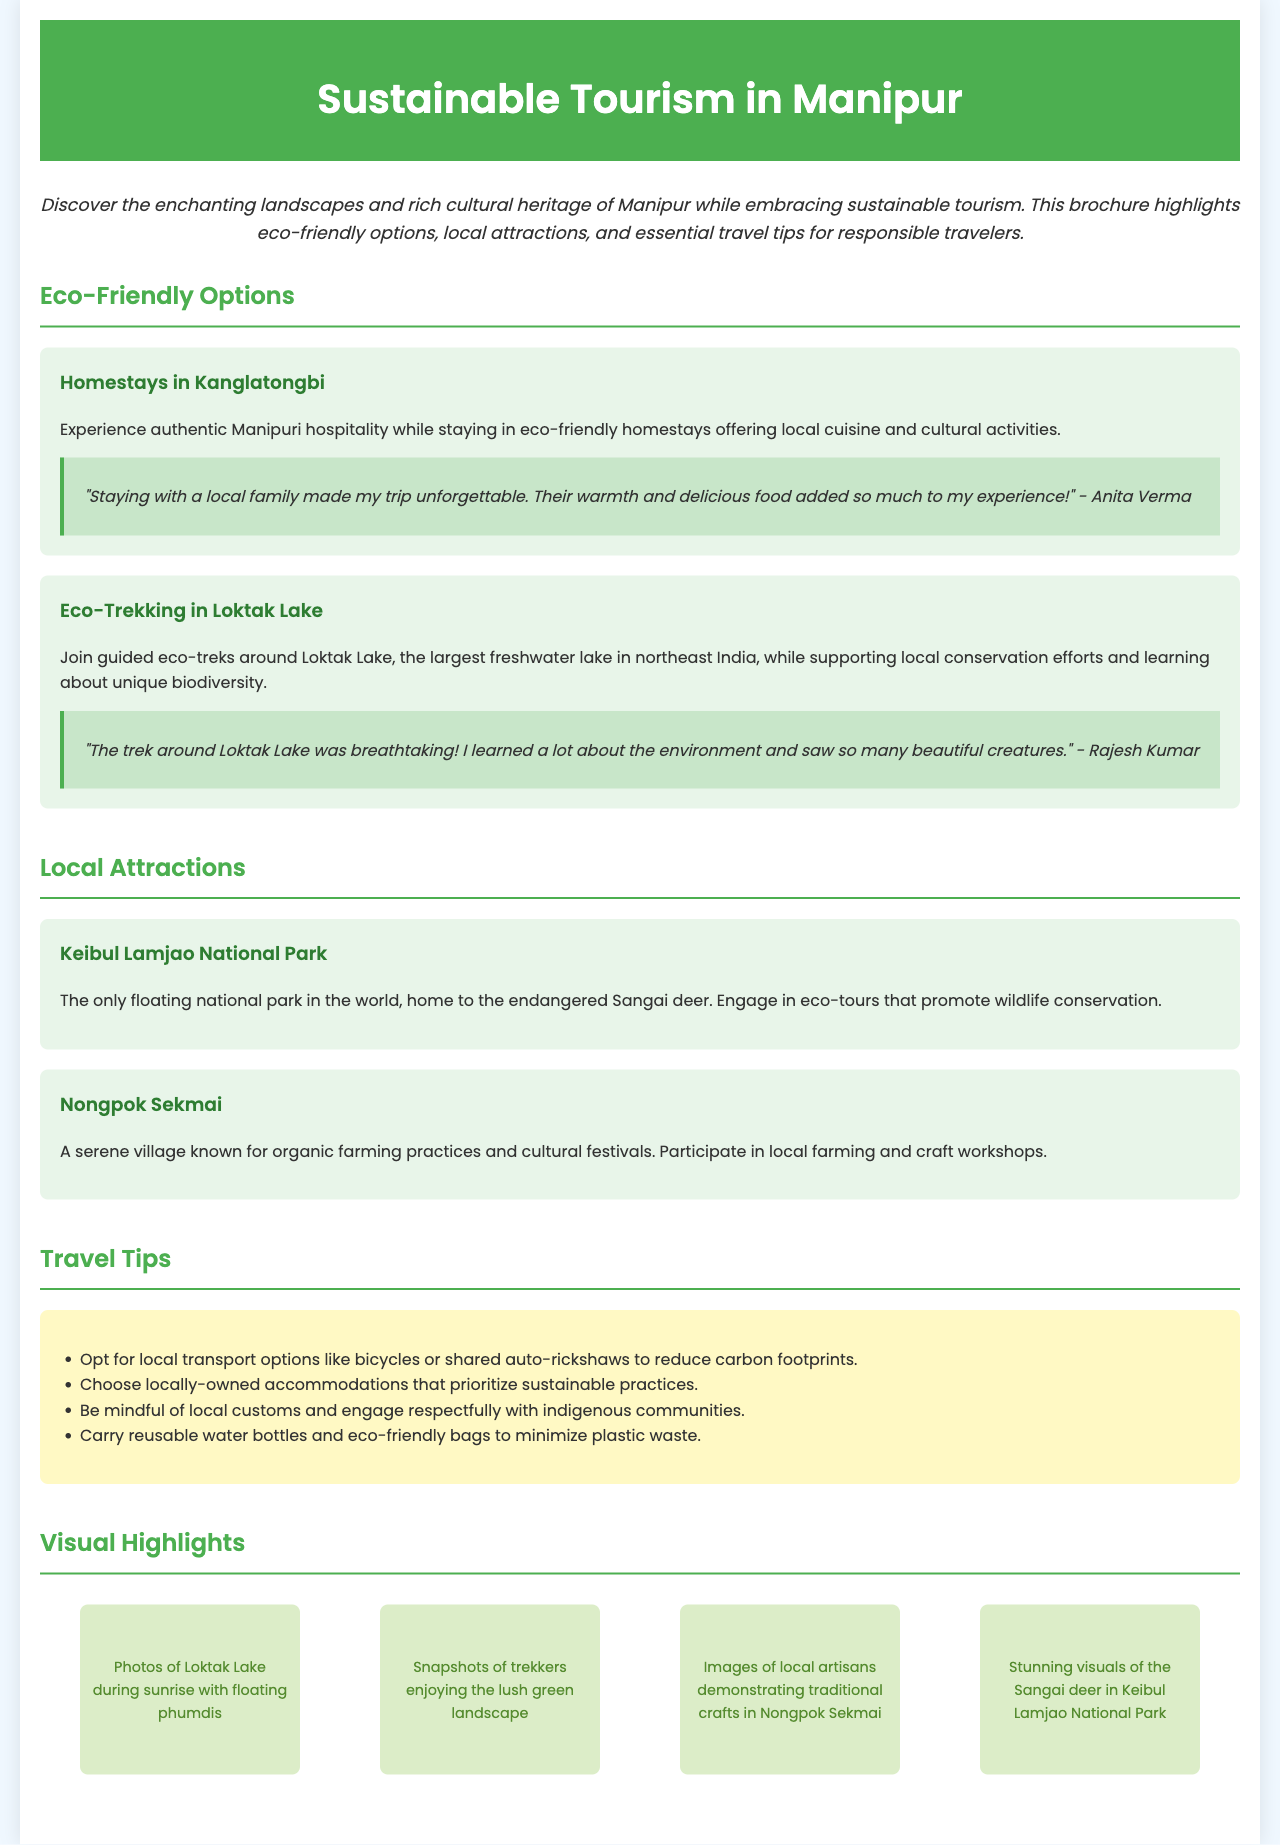What is the title of the brochure? The title is found in the header section of the document.
Answer: Sustainable Tourism in Manipur What is a key eco-friendly accommodation option mentioned? The brochure provides specific options related to eco-friendly stays.
Answer: Homestays in Kanglatongbi How many eco-friendly options are listed? The document describes the number of eco-friendly options available.
Answer: Two What is the only floating national park in the world mentioned? The brochure highlights a unique attraction that fits this description.
Answer: Keibul Lamjao National Park What travel tip suggests reducing carbon footprints? The travel tips section lists suggestions for responsible tourism practices.
Answer: Opt for local transport options Who provided a testimonial about the eco-trekking experience? The testimonial section attributes feedback to a specific traveler.
Answer: Rajesh Kumar What is the main activity promoted in Nongpok Sekmai? The document indicates specific cultural and agricultural practices in this village.
Answer: Organic farming Which colorful section contains visual highlights? The structure of the brochure indicates where visual content is compiled.
Answer: Visual Highlights 